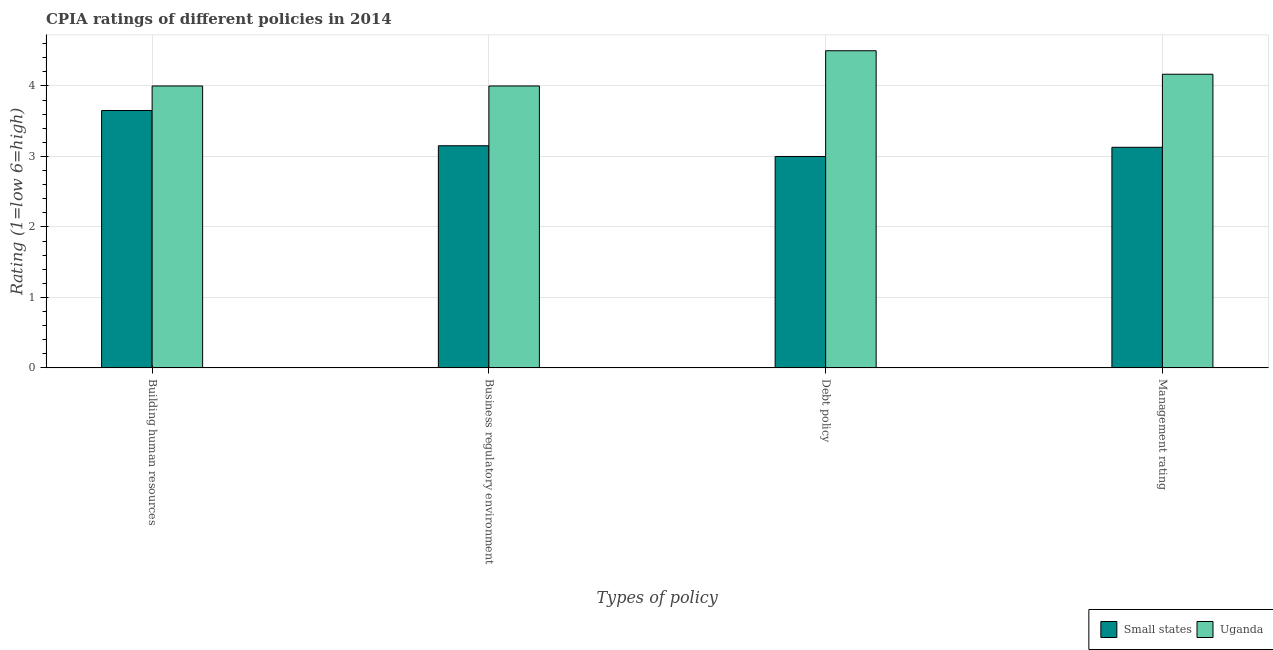Are the number of bars per tick equal to the number of legend labels?
Give a very brief answer. Yes. How many bars are there on the 4th tick from the left?
Your response must be concise. 2. What is the label of the 1st group of bars from the left?
Keep it short and to the point. Building human resources. What is the cpia rating of building human resources in Small states?
Make the answer very short. 3.65. Across all countries, what is the maximum cpia rating of management?
Provide a short and direct response. 4.17. Across all countries, what is the minimum cpia rating of management?
Keep it short and to the point. 3.13. In which country was the cpia rating of debt policy maximum?
Provide a succinct answer. Uganda. In which country was the cpia rating of debt policy minimum?
Give a very brief answer. Small states. What is the total cpia rating of building human resources in the graph?
Provide a succinct answer. 7.65. What is the difference between the cpia rating of debt policy in Small states and that in Uganda?
Make the answer very short. -1.5. What is the difference between the cpia rating of business regulatory environment in Uganda and the cpia rating of management in Small states?
Give a very brief answer. 0.87. What is the average cpia rating of business regulatory environment per country?
Offer a terse response. 3.58. What is the difference between the cpia rating of business regulatory environment and cpia rating of management in Small states?
Make the answer very short. 0.02. What is the ratio of the cpia rating of management in Uganda to that in Small states?
Provide a succinct answer. 1.33. Is the cpia rating of business regulatory environment in Uganda less than that in Small states?
Give a very brief answer. No. Is the difference between the cpia rating of business regulatory environment in Small states and Uganda greater than the difference between the cpia rating of debt policy in Small states and Uganda?
Your response must be concise. Yes. What is the difference between the highest and the second highest cpia rating of building human resources?
Provide a short and direct response. 0.35. What is the difference between the highest and the lowest cpia rating of business regulatory environment?
Give a very brief answer. 0.85. In how many countries, is the cpia rating of building human resources greater than the average cpia rating of building human resources taken over all countries?
Offer a terse response. 1. Is the sum of the cpia rating of debt policy in Small states and Uganda greater than the maximum cpia rating of management across all countries?
Give a very brief answer. Yes. What does the 1st bar from the left in Management rating represents?
Make the answer very short. Small states. What does the 1st bar from the right in Management rating represents?
Keep it short and to the point. Uganda. Are all the bars in the graph horizontal?
Provide a short and direct response. No. How many countries are there in the graph?
Keep it short and to the point. 2. Are the values on the major ticks of Y-axis written in scientific E-notation?
Provide a succinct answer. No. Does the graph contain any zero values?
Your response must be concise. No. Does the graph contain grids?
Keep it short and to the point. Yes. Where does the legend appear in the graph?
Ensure brevity in your answer.  Bottom right. How are the legend labels stacked?
Give a very brief answer. Horizontal. What is the title of the graph?
Your answer should be compact. CPIA ratings of different policies in 2014. Does "Austria" appear as one of the legend labels in the graph?
Offer a very short reply. No. What is the label or title of the X-axis?
Your response must be concise. Types of policy. What is the Rating (1=low 6=high) in Small states in Building human resources?
Your response must be concise. 3.65. What is the Rating (1=low 6=high) of Uganda in Building human resources?
Provide a succinct answer. 4. What is the Rating (1=low 6=high) in Small states in Business regulatory environment?
Ensure brevity in your answer.  3.15. What is the Rating (1=low 6=high) of Uganda in Business regulatory environment?
Your answer should be very brief. 4. What is the Rating (1=low 6=high) in Small states in Management rating?
Your answer should be very brief. 3.13. What is the Rating (1=low 6=high) of Uganda in Management rating?
Offer a terse response. 4.17. Across all Types of policy, what is the maximum Rating (1=low 6=high) in Small states?
Your answer should be compact. 3.65. Across all Types of policy, what is the minimum Rating (1=low 6=high) in Uganda?
Your answer should be very brief. 4. What is the total Rating (1=low 6=high) in Small states in the graph?
Offer a terse response. 12.93. What is the total Rating (1=low 6=high) of Uganda in the graph?
Make the answer very short. 16.67. What is the difference between the Rating (1=low 6=high) in Small states in Building human resources and that in Business regulatory environment?
Your response must be concise. 0.5. What is the difference between the Rating (1=low 6=high) of Small states in Building human resources and that in Debt policy?
Make the answer very short. 0.65. What is the difference between the Rating (1=low 6=high) of Small states in Building human resources and that in Management rating?
Your response must be concise. 0.52. What is the difference between the Rating (1=low 6=high) of Uganda in Building human resources and that in Management rating?
Give a very brief answer. -0.17. What is the difference between the Rating (1=low 6=high) of Small states in Business regulatory environment and that in Debt policy?
Give a very brief answer. 0.15. What is the difference between the Rating (1=low 6=high) in Uganda in Business regulatory environment and that in Debt policy?
Your answer should be very brief. -0.5. What is the difference between the Rating (1=low 6=high) of Small states in Business regulatory environment and that in Management rating?
Give a very brief answer. 0.02. What is the difference between the Rating (1=low 6=high) of Small states in Debt policy and that in Management rating?
Provide a succinct answer. -0.13. What is the difference between the Rating (1=low 6=high) of Small states in Building human resources and the Rating (1=low 6=high) of Uganda in Business regulatory environment?
Give a very brief answer. -0.35. What is the difference between the Rating (1=low 6=high) of Small states in Building human resources and the Rating (1=low 6=high) of Uganda in Debt policy?
Your response must be concise. -0.85. What is the difference between the Rating (1=low 6=high) of Small states in Building human resources and the Rating (1=low 6=high) of Uganda in Management rating?
Keep it short and to the point. -0.51. What is the difference between the Rating (1=low 6=high) of Small states in Business regulatory environment and the Rating (1=low 6=high) of Uganda in Debt policy?
Offer a terse response. -1.35. What is the difference between the Rating (1=low 6=high) of Small states in Business regulatory environment and the Rating (1=low 6=high) of Uganda in Management rating?
Give a very brief answer. -1.01. What is the difference between the Rating (1=low 6=high) of Small states in Debt policy and the Rating (1=low 6=high) of Uganda in Management rating?
Your response must be concise. -1.17. What is the average Rating (1=low 6=high) in Small states per Types of policy?
Ensure brevity in your answer.  3.23. What is the average Rating (1=low 6=high) of Uganda per Types of policy?
Provide a succinct answer. 4.17. What is the difference between the Rating (1=low 6=high) of Small states and Rating (1=low 6=high) of Uganda in Building human resources?
Your answer should be very brief. -0.35. What is the difference between the Rating (1=low 6=high) of Small states and Rating (1=low 6=high) of Uganda in Business regulatory environment?
Provide a succinct answer. -0.85. What is the difference between the Rating (1=low 6=high) of Small states and Rating (1=low 6=high) of Uganda in Debt policy?
Ensure brevity in your answer.  -1.5. What is the difference between the Rating (1=low 6=high) in Small states and Rating (1=low 6=high) in Uganda in Management rating?
Provide a succinct answer. -1.04. What is the ratio of the Rating (1=low 6=high) in Small states in Building human resources to that in Business regulatory environment?
Make the answer very short. 1.16. What is the ratio of the Rating (1=low 6=high) in Small states in Building human resources to that in Debt policy?
Your answer should be very brief. 1.22. What is the ratio of the Rating (1=low 6=high) in Small states in Business regulatory environment to that in Debt policy?
Keep it short and to the point. 1.05. What is the ratio of the Rating (1=low 6=high) of Uganda in Business regulatory environment to that in Debt policy?
Your response must be concise. 0.89. What is the ratio of the Rating (1=low 6=high) of Uganda in Business regulatory environment to that in Management rating?
Your answer should be very brief. 0.96. What is the difference between the highest and the second highest Rating (1=low 6=high) in Uganda?
Make the answer very short. 0.33. What is the difference between the highest and the lowest Rating (1=low 6=high) in Small states?
Ensure brevity in your answer.  0.65. 